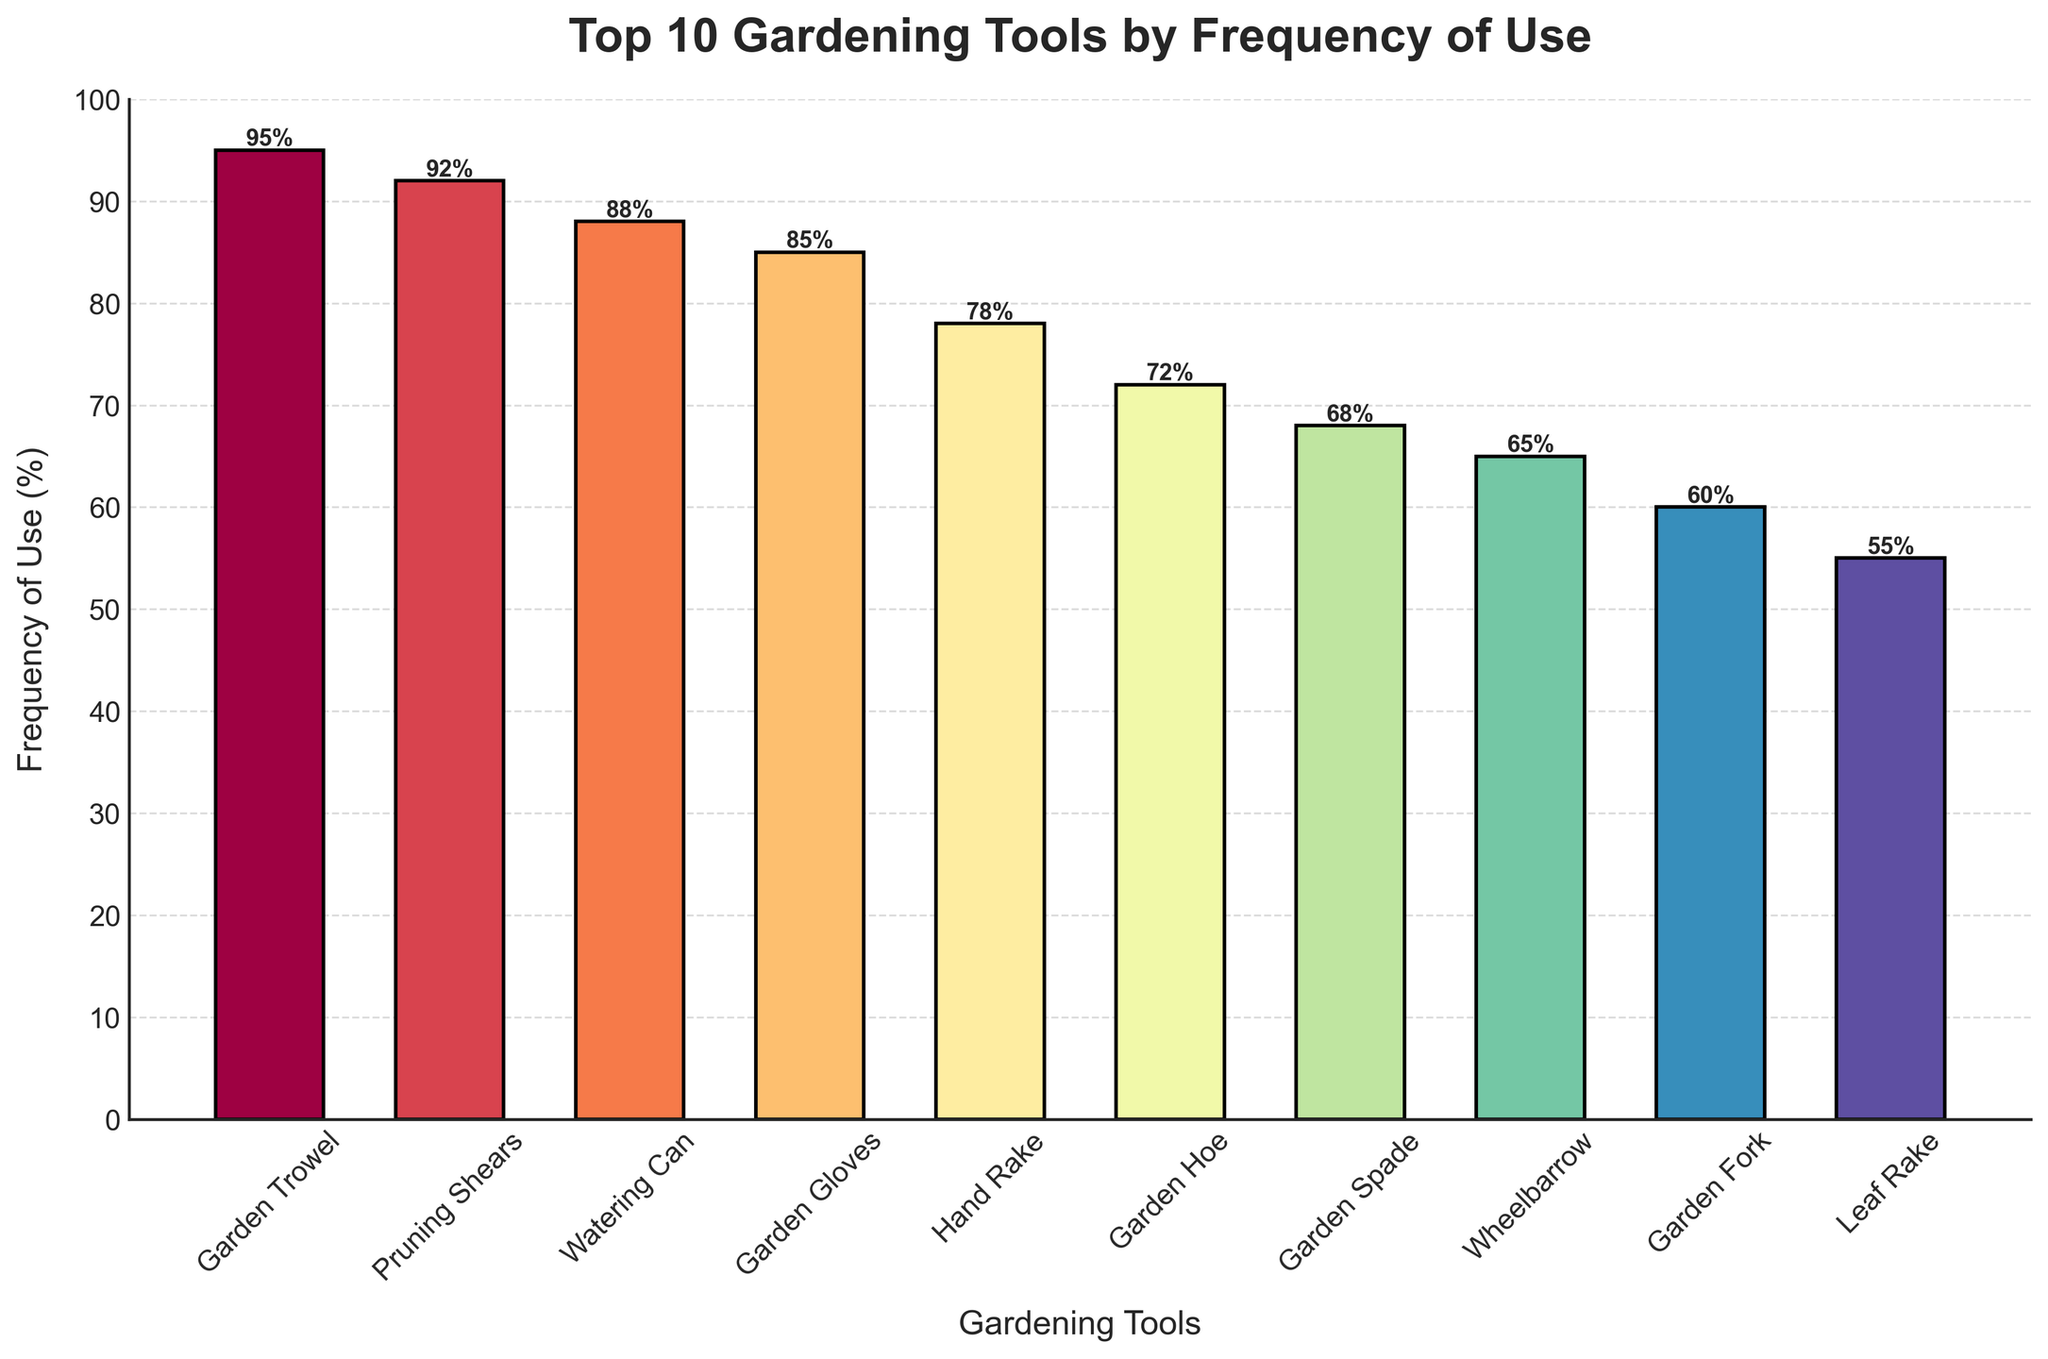Which gardening tool is used the most frequently? The bar corresponding to the Garden Trowel is the highest among all the bars in the figure, indicating it is used the most frequently at 95%.
Answer: Garden Trowel Which gardening tool is used the least frequently? The bar corresponding to the Leaf Rake is the shortest among all the bars in the figure, indicating it is used the least frequently at 55%.
Answer: Leaf Rake Which tools have a frequency of use greater than or equal to 85%? Examining the bars that reach the 85% mark or higher, the tools are Garden Trowel, Pruning Shears, Watering Can, and Garden Gloves.
Answer: Garden Trowel, Pruning Shears, Watering Can, Garden Gloves How many tools have a frequency of use higher than 70%? Counting the bars that are higher than the 70% mark in the figure, we see Garden Trowel, Pruning Shears, Watering Can, Garden Gloves, Hand Rake, and Garden Hoe. That makes 6 tools.
Answer: 6 What is the average frequency of use for the top 3 most frequently used tools? The top 3 tools are Garden Trowel, Pruning Shears, and Watering Can. Summing their frequencies (95 + 92 + 88) gives 275. Dividing by 3, the average is 275/3 ≈ 91.67%.
Answer: 91.67% Does the Garden Hoe have a higher frequency of use than the Garden Spade? By comparing the height of the bars, the Garden Hoe bar is taller than the Garden Spade bar (72% vs. 68%).
Answer: Yes Are there any tools with a frequency of use between 60% and 70%? The bars in this range are those for the Garden Spade (68%) and the Garden Fork (60%). These are the tools with a frequency of use between 60% and 70%.
Answer: Garden Spade, Garden Fork Which tool has a usage frequency closest to 80%? Comparing the bars to the 80% mark, the Hand Rake at 78% is the closest to 80%.
Answer: Hand Rake How much less frequently is the Wheelbarrow used compared to the Garden Trowel? Subtracting the Wheelbarrow frequency (65%) from the Garden Trowel frequency (95%) gives a difference of 30%.
Answer: 30% What is the combined frequency of use for the tools with a usage of less than 70%? Adding the frequencies of Garden Hoe (72% but still considered), Garden Spade, Wheelbarrow, Garden Fork, and Leaf Rake (68% + 65% + 60% + 55%) gives a total of 313%.
Answer: 313% 